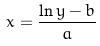<formula> <loc_0><loc_0><loc_500><loc_500>x = \frac { \ln y - b } { a }</formula> 